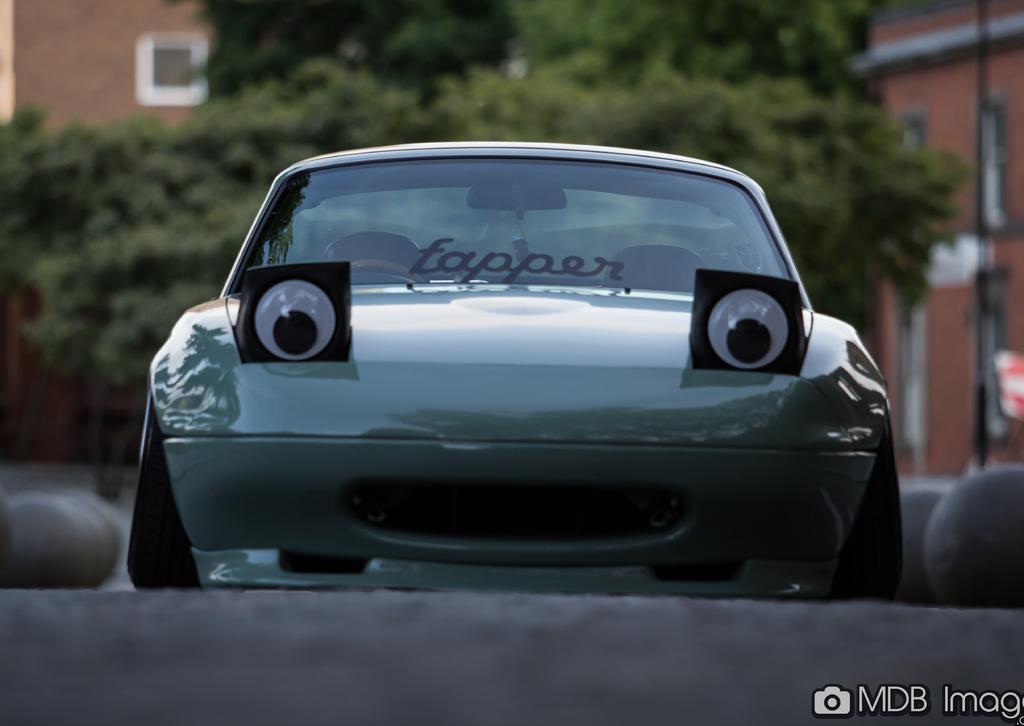Please provide a concise description of this image. In this image at front there is a car on the road. At the background there are trees and buildings. 